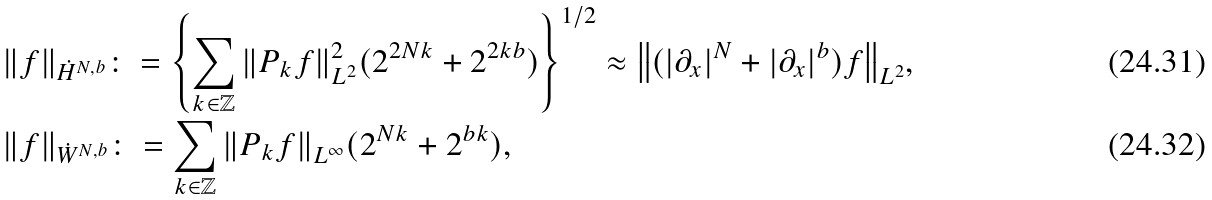Convert formula to latex. <formula><loc_0><loc_0><loc_500><loc_500>& { \| f \| } _ { \dot { H } ^ { N , b } } \colon = \left \{ \sum _ { k \in \mathbb { Z } } { \| P _ { k } f \| } ^ { 2 } _ { L ^ { 2 } } ( 2 ^ { 2 N k } + 2 ^ { 2 k b } ) \right \} ^ { 1 / 2 } \approx { \left \| ( | \partial _ { x } | ^ { N } + | \partial _ { x } | ^ { b } ) f \right \| } _ { L ^ { 2 } } , \\ & { \| f \| } _ { \dot { W } ^ { N , b } } \colon = \sum _ { k \in \mathbb { Z } } { \| P _ { k } f \| } _ { L ^ { \infty } } ( 2 ^ { N k } + 2 ^ { b k } ) ,</formula> 